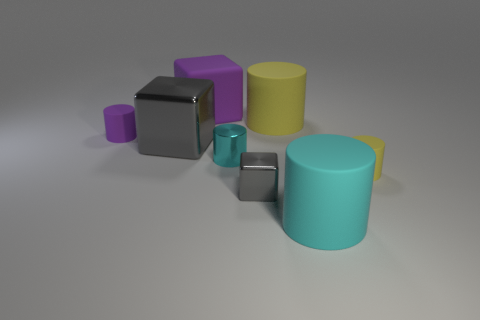Subtract all tiny purple cylinders. How many cylinders are left? 4 Add 1 big purple rubber blocks. How many objects exist? 9 Subtract all purple blocks. How many blocks are left? 2 Subtract all cubes. How many objects are left? 5 Add 2 small purple rubber cylinders. How many small purple rubber cylinders exist? 3 Subtract 0 brown blocks. How many objects are left? 8 Subtract 2 cylinders. How many cylinders are left? 3 Subtract all red cylinders. Subtract all red cubes. How many cylinders are left? 5 Subtract all red blocks. How many yellow cylinders are left? 2 Subtract all brown rubber things. Subtract all large gray objects. How many objects are left? 7 